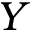<formula> <loc_0><loc_0><loc_500><loc_500>Y</formula> 